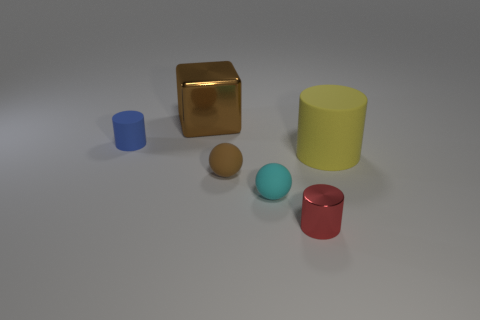Does the block have the same color as the matte sphere left of the cyan object?
Your answer should be very brief. Yes. What number of tiny objects have the same color as the big shiny block?
Provide a succinct answer. 1. There is a matte cylinder right of the small brown thing; what is its size?
Offer a very short reply. Large. Are there the same number of yellow rubber objects that are behind the large cube and shiny cylinders behind the small blue matte cylinder?
Give a very brief answer. Yes. The object behind the rubber object that is behind the rubber cylinder that is in front of the blue rubber thing is what color?
Your answer should be compact. Brown. How many brown objects are both behind the tiny blue rubber thing and in front of the big yellow cylinder?
Keep it short and to the point. 0. Do the large object behind the yellow object and the rubber ball to the left of the small cyan rubber thing have the same color?
Your answer should be compact. Yes. The brown thing that is the same shape as the small cyan object is what size?
Your answer should be compact. Small. There is a small cyan object; are there any tiny cylinders in front of it?
Provide a succinct answer. Yes. Is the number of red things that are to the left of the large yellow matte cylinder the same as the number of tiny cyan spheres?
Your response must be concise. Yes. 